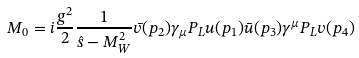<formula> <loc_0><loc_0><loc_500><loc_500>M _ { 0 } = i \frac { g ^ { 2 } } { 2 } \frac { 1 } { \hat { s } - M _ { W } ^ { 2 } } \bar { v } ( p _ { 2 } ) \gamma _ { \mu } P _ { L } u ( p _ { 1 } ) \bar { u } ( p _ { 3 } ) \gamma ^ { \mu } P _ { L } v ( p _ { 4 } )</formula> 